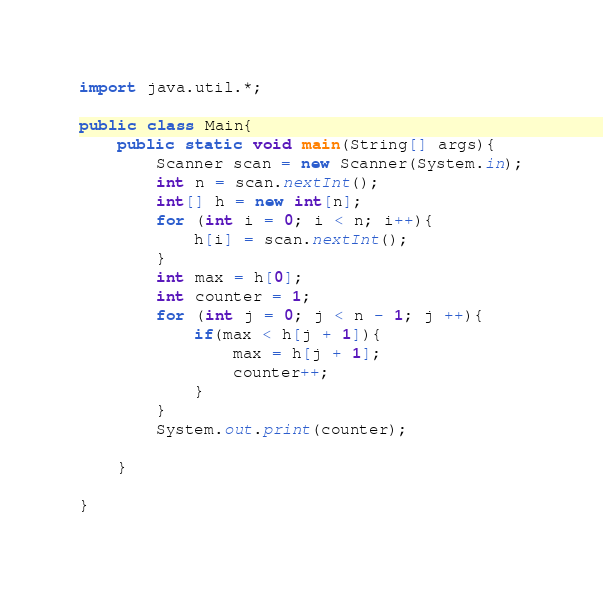<code> <loc_0><loc_0><loc_500><loc_500><_Java_>import java.util.*;
 
public class Main{
	public static void main(String[] args){
    	Scanner scan = new Scanner(System.in);
      	int n = scan.nextInt();
      	int[] h = new int[n];
      	for (int i = 0; i < n; i++){
        	h[i] = scan.nextInt();
        }
      	int max = h[0];
      	int counter = 1;
      	for (int j = 0; j < n - 1; j ++){
        	if(max < h[j + 1]){
            	max = h[j + 1];
              	counter++;
            }
        }
      	System.out.print(counter);
    
    }
 
}</code> 